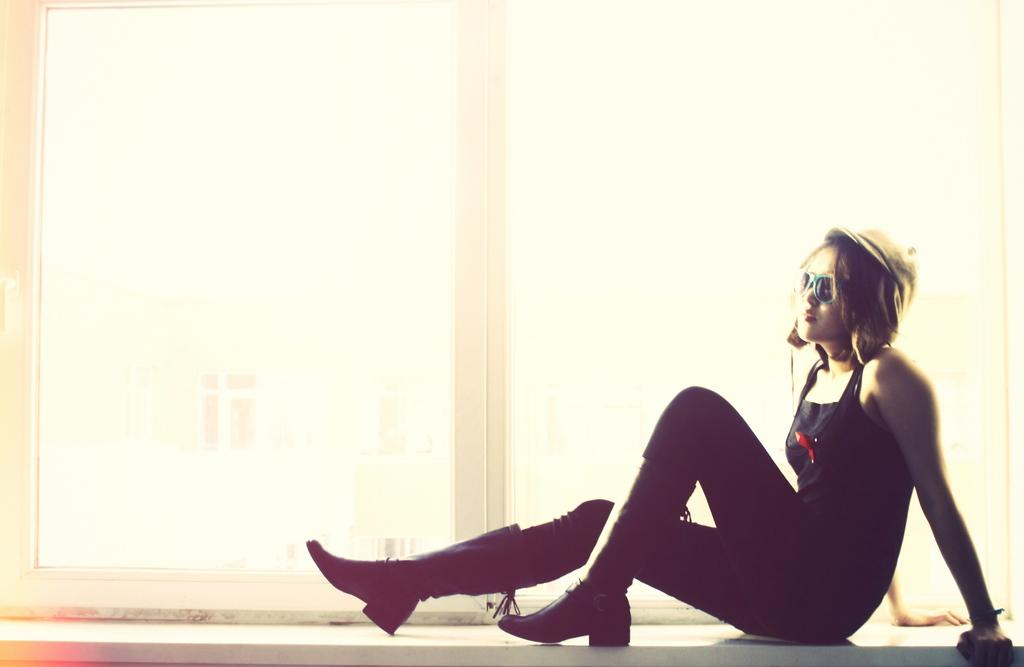Who or what is present in the image? There is a person in the image. What is the person wearing? The person is wearing a black dress. Where is the person sitting in the image? The person is sitting on a window. What can be seen through the window? There is another building visible through the window. What type of string is being used to hold the letters together in the image? There is no string or letters present in the image. 